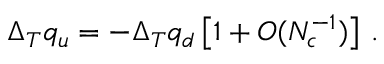<formula> <loc_0><loc_0><loc_500><loc_500>\Delta _ { T } q _ { u } = - \Delta _ { T } q _ { d } \left [ 1 + O ( N _ { c } ^ { - 1 } ) \right ] \, .</formula> 